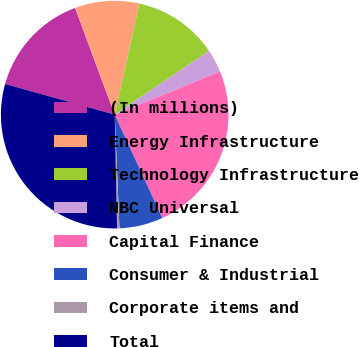<chart> <loc_0><loc_0><loc_500><loc_500><pie_chart><fcel>(In millions)<fcel>Energy Infrastructure<fcel>Technology Infrastructure<fcel>NBC Universal<fcel>Capital Finance<fcel>Consumer & Industrial<fcel>Corporate items and<fcel>Total<nl><fcel>15.0%<fcel>9.14%<fcel>12.07%<fcel>3.27%<fcel>24.32%<fcel>6.2%<fcel>0.34%<fcel>29.67%<nl></chart> 